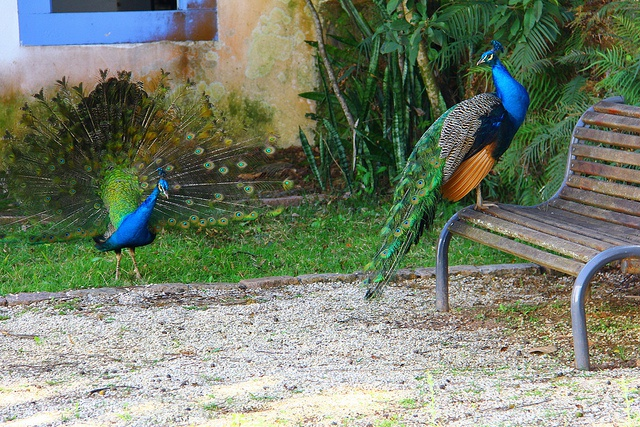Describe the objects in this image and their specific colors. I can see bird in lavender, black, darkgreen, and gray tones, bench in lavender, gray, and darkgray tones, and bird in lavender, black, darkgreen, gray, and teal tones in this image. 